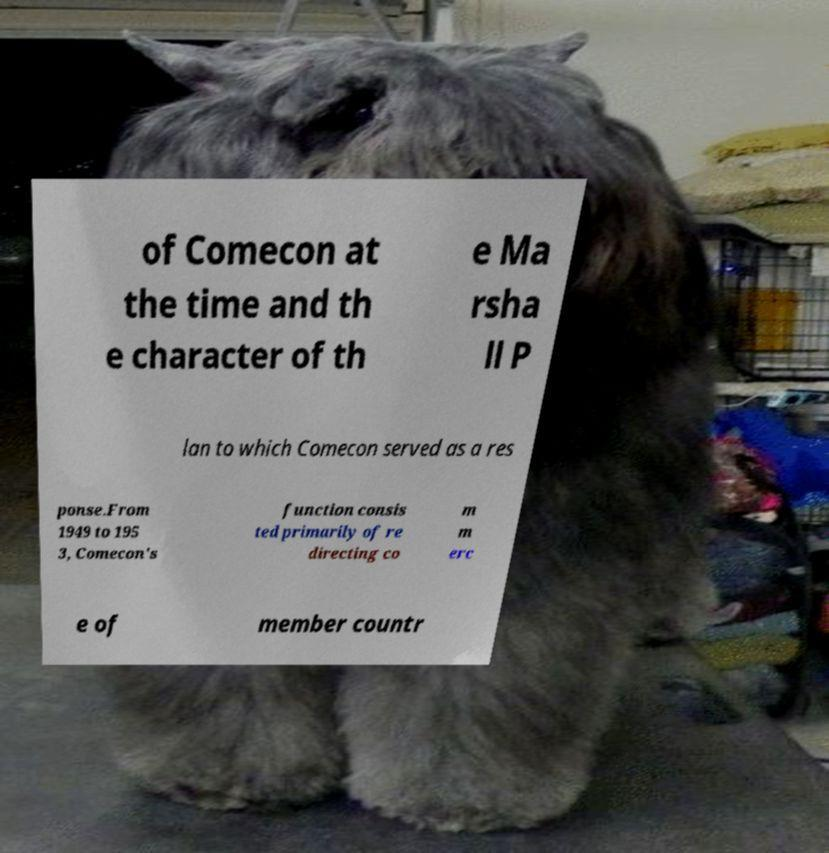What messages or text are displayed in this image? I need them in a readable, typed format. of Comecon at the time and th e character of th e Ma rsha ll P lan to which Comecon served as a res ponse.From 1949 to 195 3, Comecon's function consis ted primarily of re directing co m m erc e of member countr 